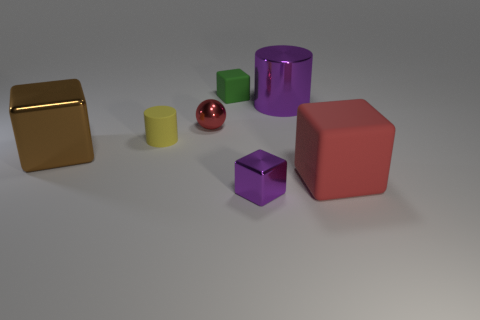Subtract 1 cubes. How many cubes are left? 3 Subtract all purple cubes. How many cubes are left? 3 Subtract all gray cubes. Subtract all green cylinders. How many cubes are left? 4 Add 2 metal cubes. How many objects exist? 9 Subtract all spheres. How many objects are left? 6 Subtract all small green blocks. Subtract all tiny red metal objects. How many objects are left? 5 Add 7 small red metal balls. How many small red metal balls are left? 8 Add 6 tiny brown cylinders. How many tiny brown cylinders exist? 6 Subtract 1 red cubes. How many objects are left? 6 